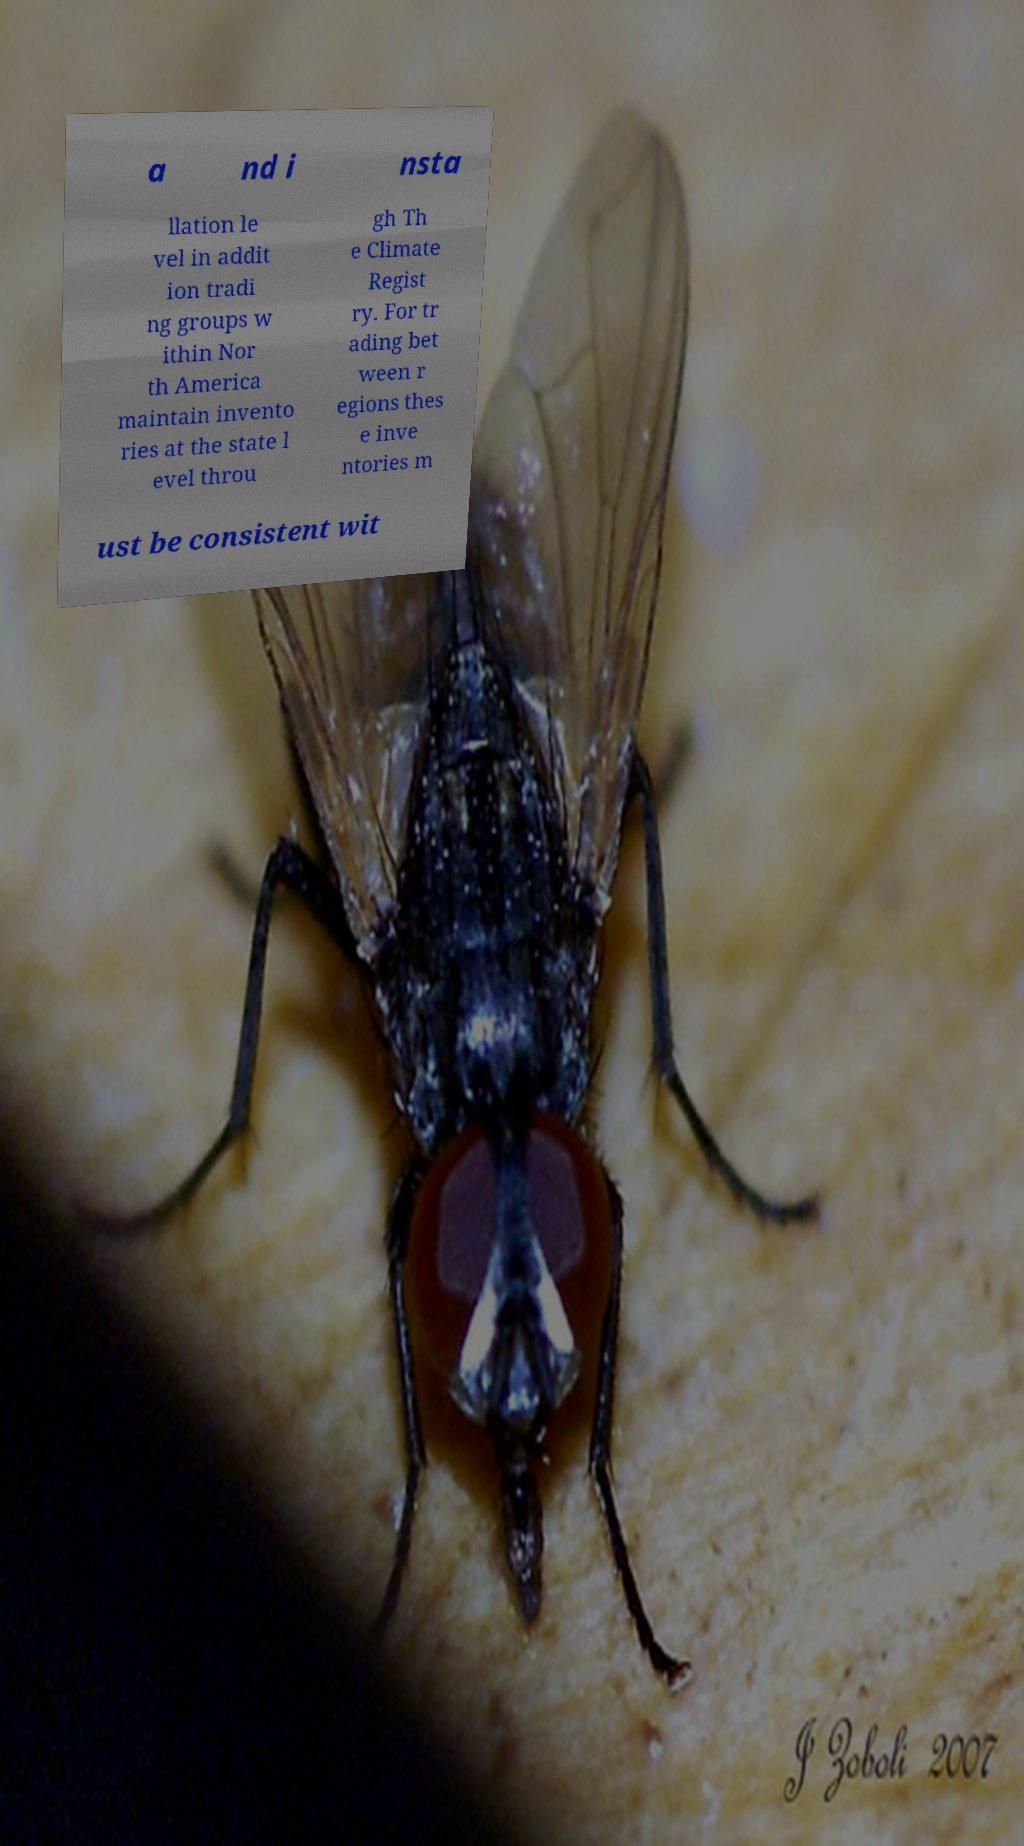I need the written content from this picture converted into text. Can you do that? a nd i nsta llation le vel in addit ion tradi ng groups w ithin Nor th America maintain invento ries at the state l evel throu gh Th e Climate Regist ry. For tr ading bet ween r egions thes e inve ntories m ust be consistent wit 